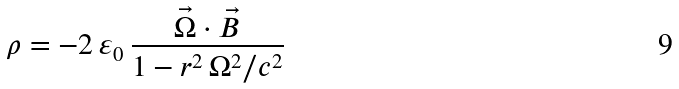Convert formula to latex. <formula><loc_0><loc_0><loc_500><loc_500>\rho = - 2 \, \varepsilon _ { 0 } \, \frac { \vec { \Omega } \cdot \vec { B } } { 1 - r ^ { 2 } \, \Omega ^ { 2 } / c ^ { 2 } }</formula> 